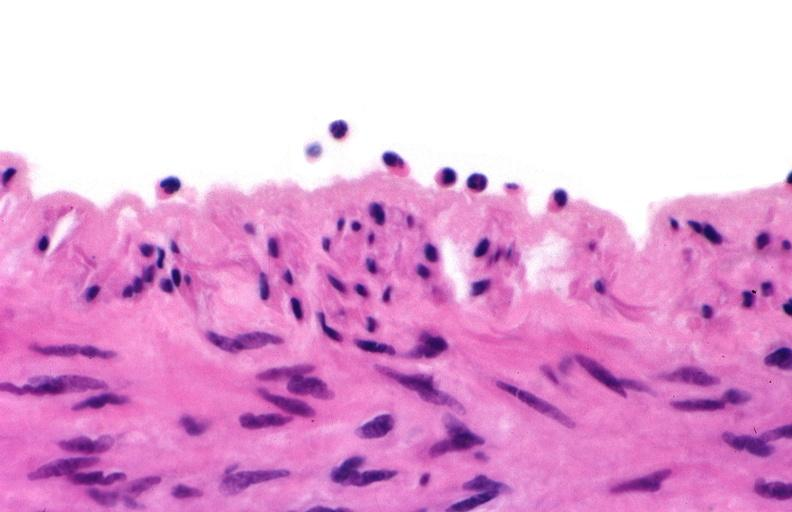s vasculature present?
Answer the question using a single word or phrase. Yes 